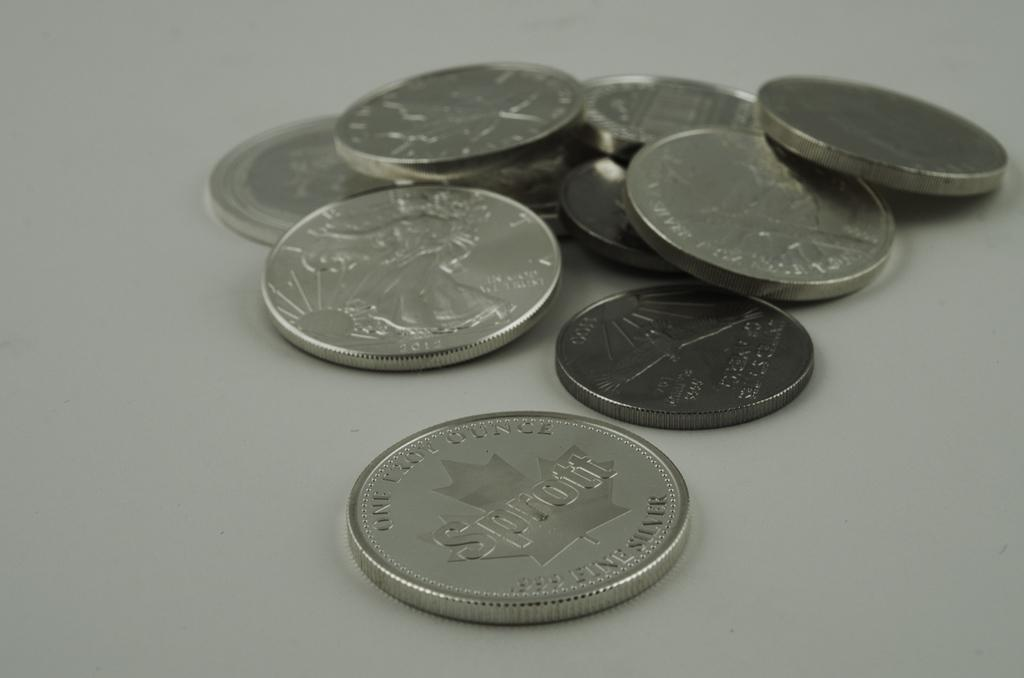Provide a one-sentence caption for the provided image. Several coins with one of them having the word Sprott on it. 